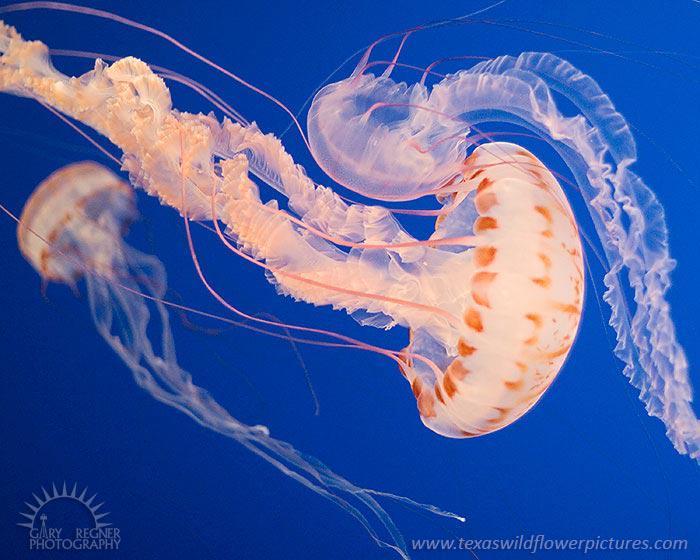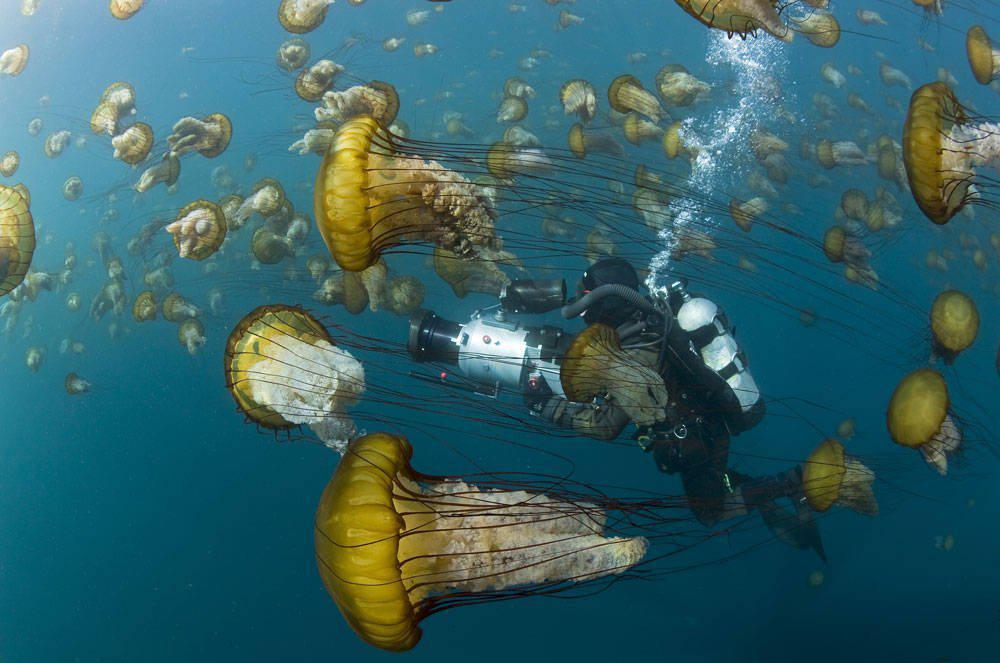The first image is the image on the left, the second image is the image on the right. Analyze the images presented: Is the assertion "Both images contain a single jellyfish." valid? Answer yes or no. No. 